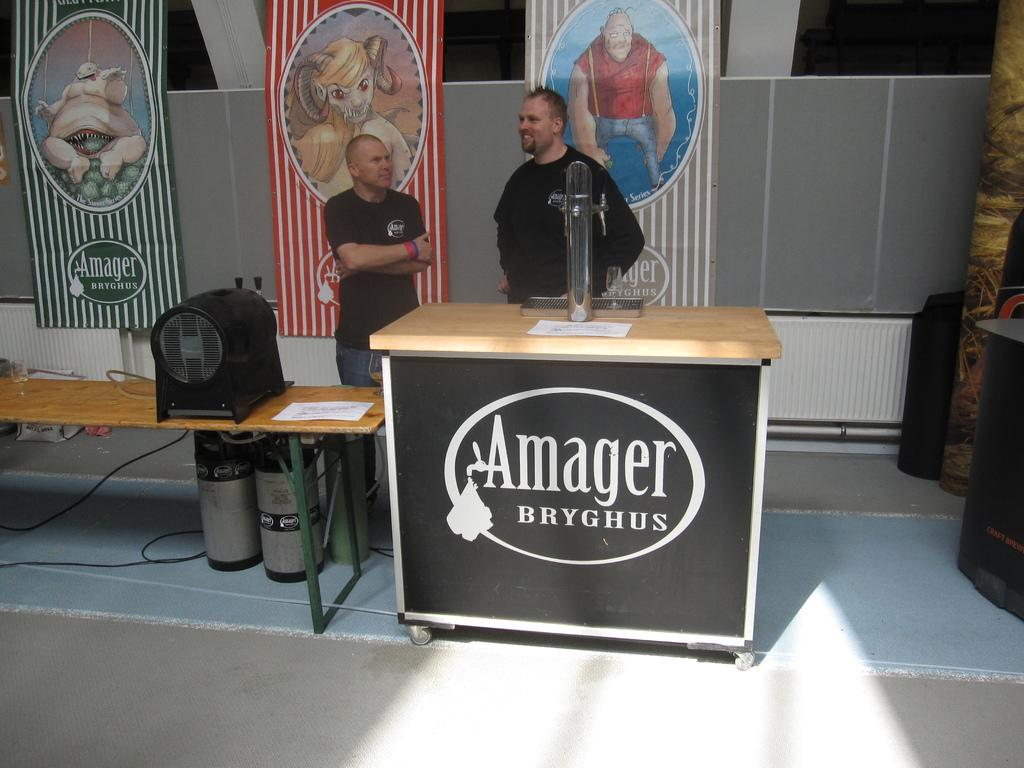How many people are in the image? There are two men standing in the image. What is in front of the men? There is a table in front of the men. What can be seen in the background of the image? There are three posts in the background of the image. What is special about the posters on the posts? The posters on the posts are animated. What type of crime is being committed in the image? There is no crime being committed in the image. What does the tongue of the man on the left look like? There is no information about the men's tongues in the image. 